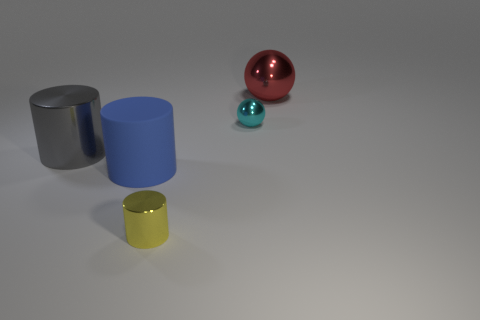What is the color of the big metallic thing that is behind the large metal thing that is on the left side of the metallic cylinder that is to the right of the gray shiny object?
Provide a succinct answer. Red. There is a big shiny object on the left side of the big sphere; is it the same shape as the small metal object on the right side of the yellow cylinder?
Your response must be concise. No. How many cylinders are there?
Your answer should be compact. 3. The other rubber cylinder that is the same size as the gray cylinder is what color?
Make the answer very short. Blue. Does the sphere on the left side of the red metal sphere have the same material as the large object that is on the left side of the rubber cylinder?
Provide a short and direct response. Yes. What size is the cylinder that is behind the big cylinder in front of the gray shiny thing?
Keep it short and to the point. Large. What is the material of the small thing to the right of the tiny metallic cylinder?
Give a very brief answer. Metal. What number of objects are either large things that are to the left of the big red sphere or objects on the left side of the yellow shiny cylinder?
Your answer should be compact. 2. What material is the yellow thing that is the same shape as the large blue thing?
Offer a very short reply. Metal. Is the color of the metal object to the left of the blue rubber cylinder the same as the shiny sphere behind the small cyan shiny ball?
Offer a terse response. No. 